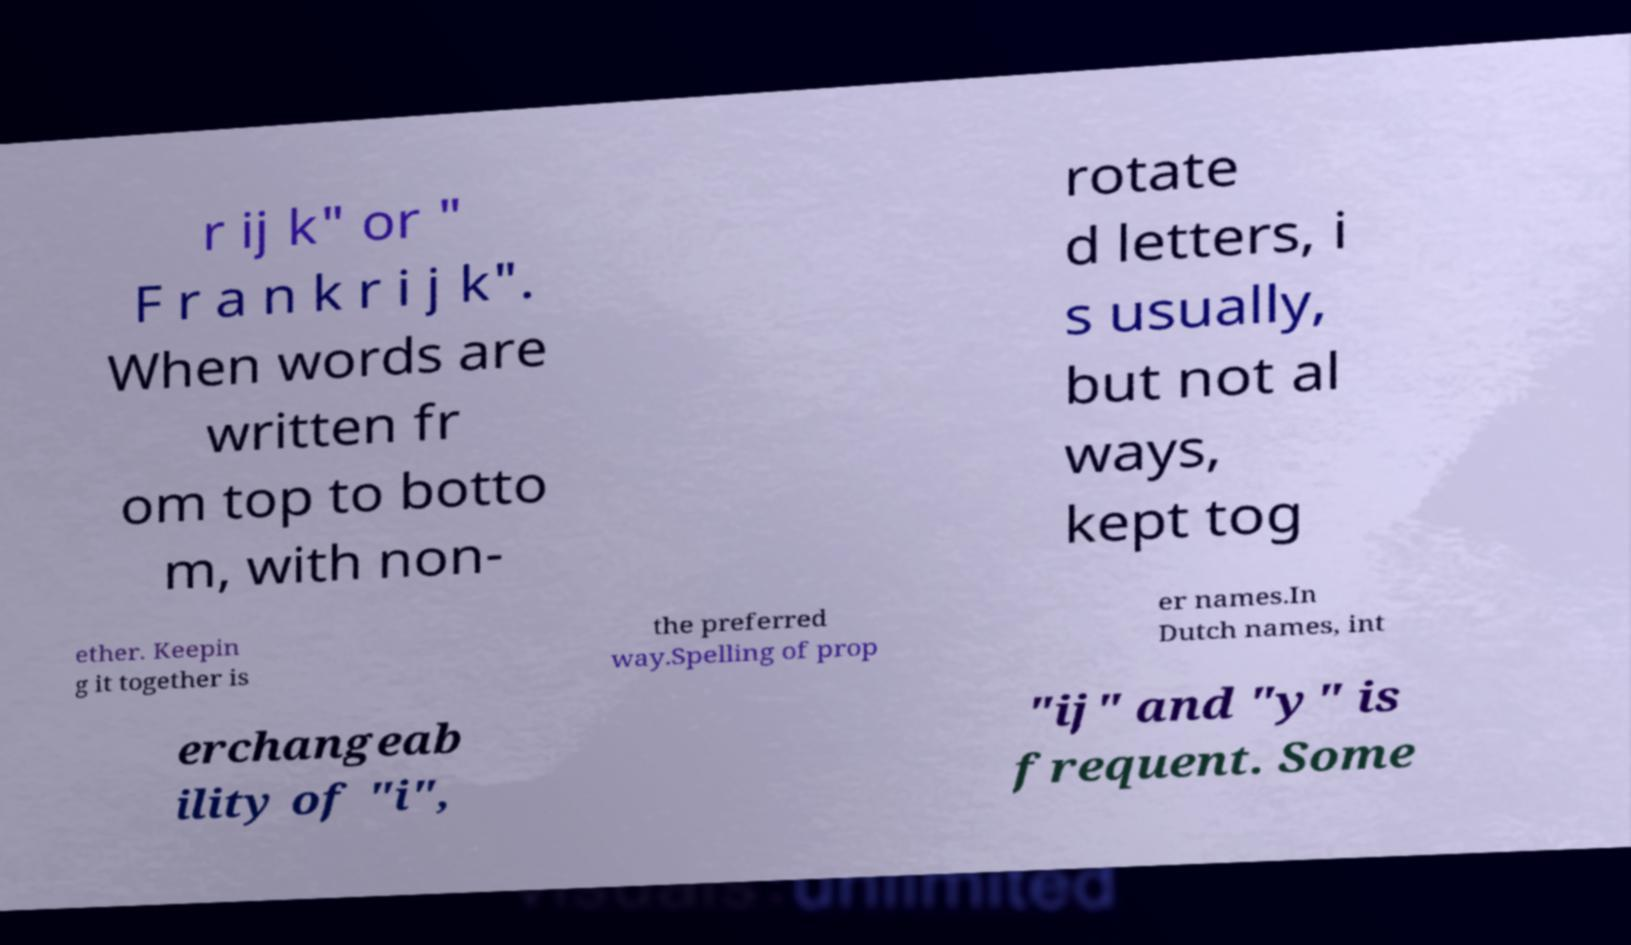Please read and relay the text visible in this image. What does it say? r ij k" or " F r a n k r i j k". When words are written fr om top to botto m, with non- rotate d letters, i s usually, but not al ways, kept tog ether. Keepin g it together is the preferred way.Spelling of prop er names.In Dutch names, int erchangeab ility of "i", "ij" and "y" is frequent. Some 